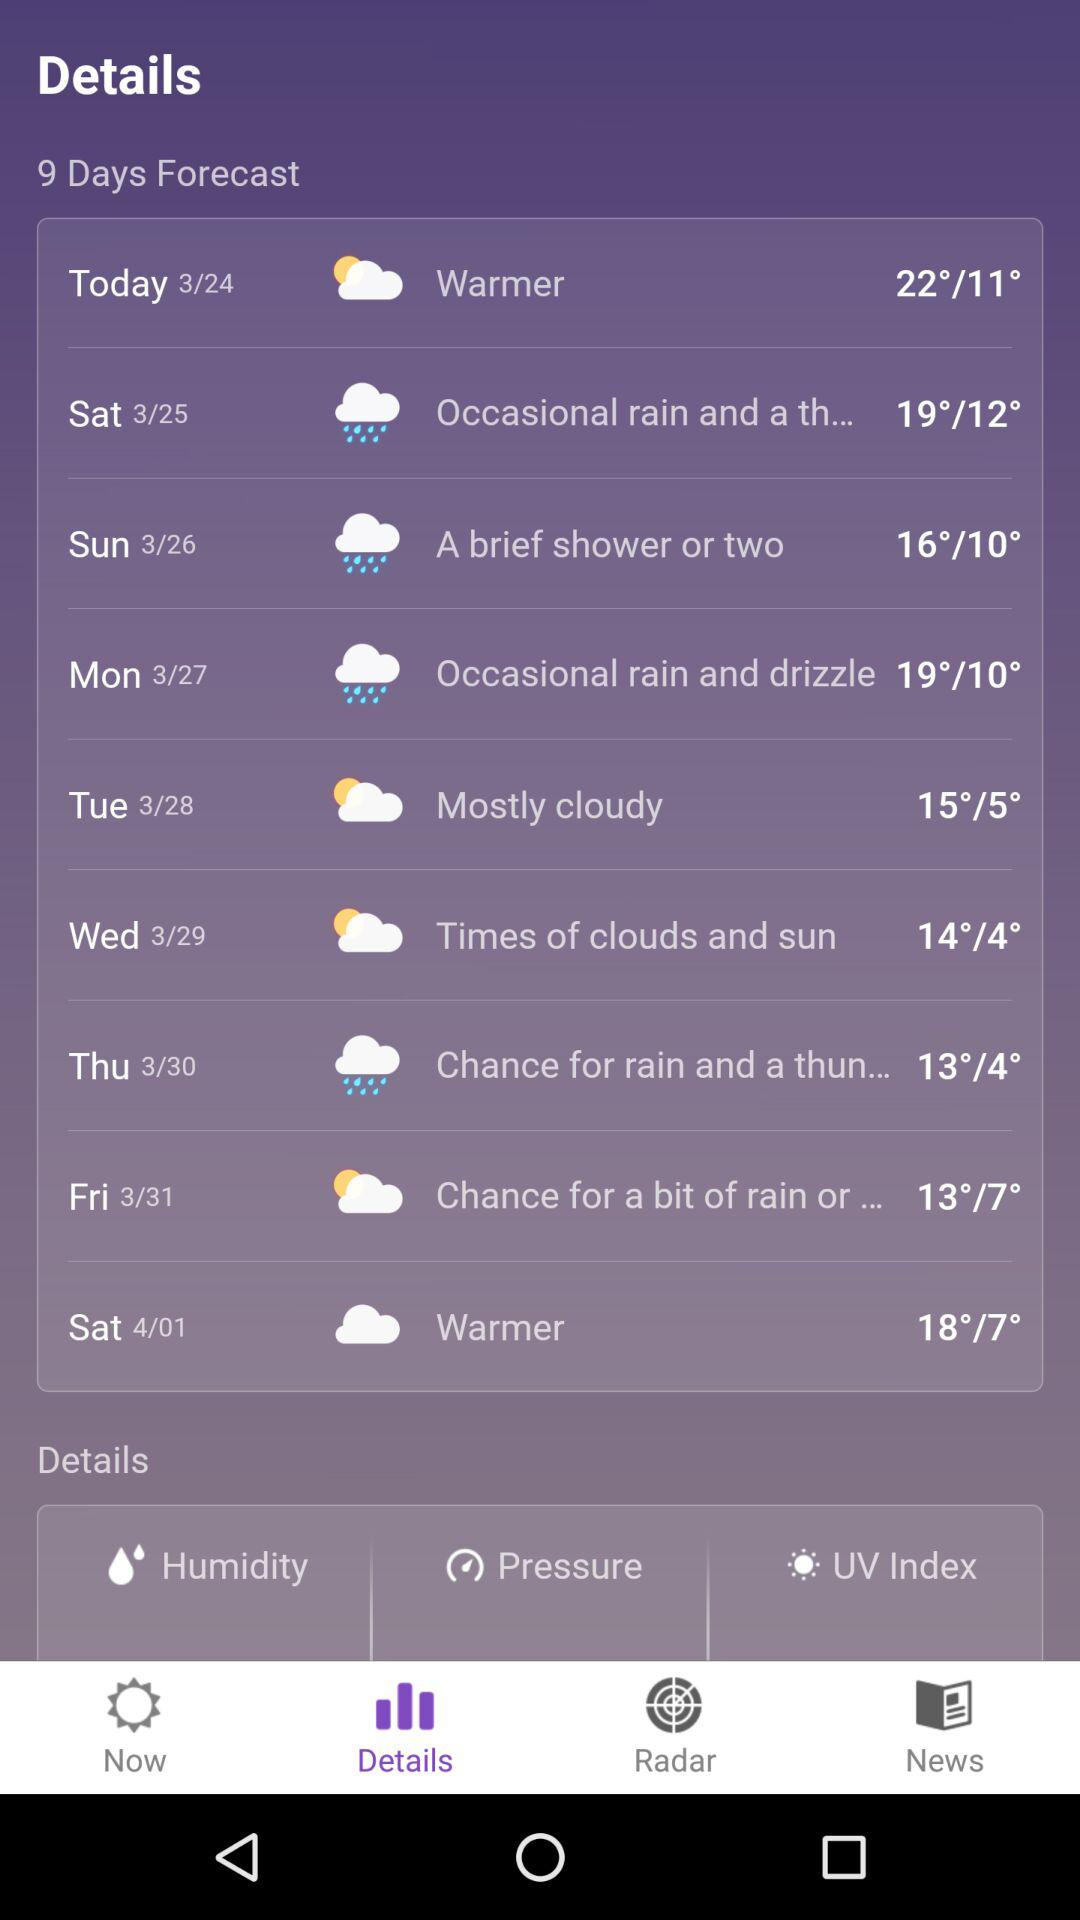What is the weather like on Tuesday? The weather is mostly cloudy. 